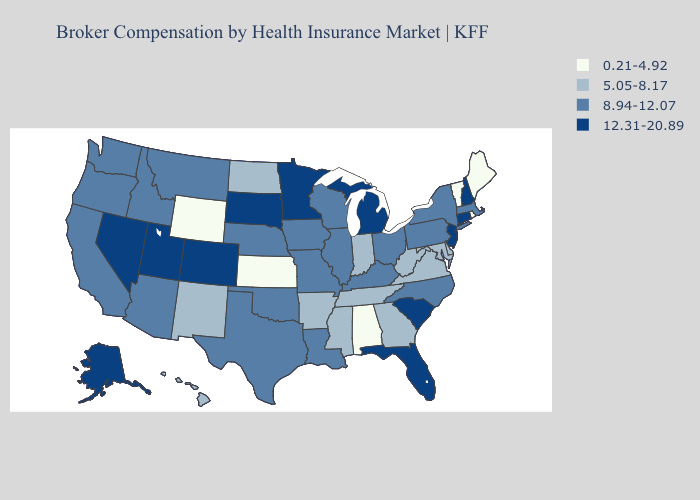What is the lowest value in states that border Mississippi?
Concise answer only. 0.21-4.92. What is the lowest value in the South?
Short answer required. 0.21-4.92. Does Kansas have the highest value in the USA?
Keep it brief. No. Does Hawaii have a lower value than Alabama?
Answer briefly. No. What is the value of Vermont?
Be succinct. 0.21-4.92. Name the states that have a value in the range 0.21-4.92?
Quick response, please. Alabama, Kansas, Maine, Rhode Island, Vermont, Wyoming. Does the first symbol in the legend represent the smallest category?
Keep it brief. Yes. Name the states that have a value in the range 5.05-8.17?
Be succinct. Arkansas, Delaware, Georgia, Hawaii, Indiana, Maryland, Mississippi, New Mexico, North Dakota, Tennessee, Virginia, West Virginia. What is the lowest value in the USA?
Give a very brief answer. 0.21-4.92. Does Wisconsin have a lower value than New York?
Keep it brief. No. What is the highest value in the West ?
Write a very short answer. 12.31-20.89. Does Louisiana have the highest value in the USA?
Be succinct. No. Does Pennsylvania have the same value as Minnesota?
Keep it brief. No. What is the lowest value in the USA?
Keep it brief. 0.21-4.92. Is the legend a continuous bar?
Give a very brief answer. No. 